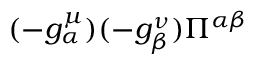<formula> <loc_0><loc_0><loc_500><loc_500>( - g _ { \alpha } ^ { \mu } ) ( - g _ { \beta } ^ { \nu } ) \Pi ^ { \alpha \beta }</formula> 